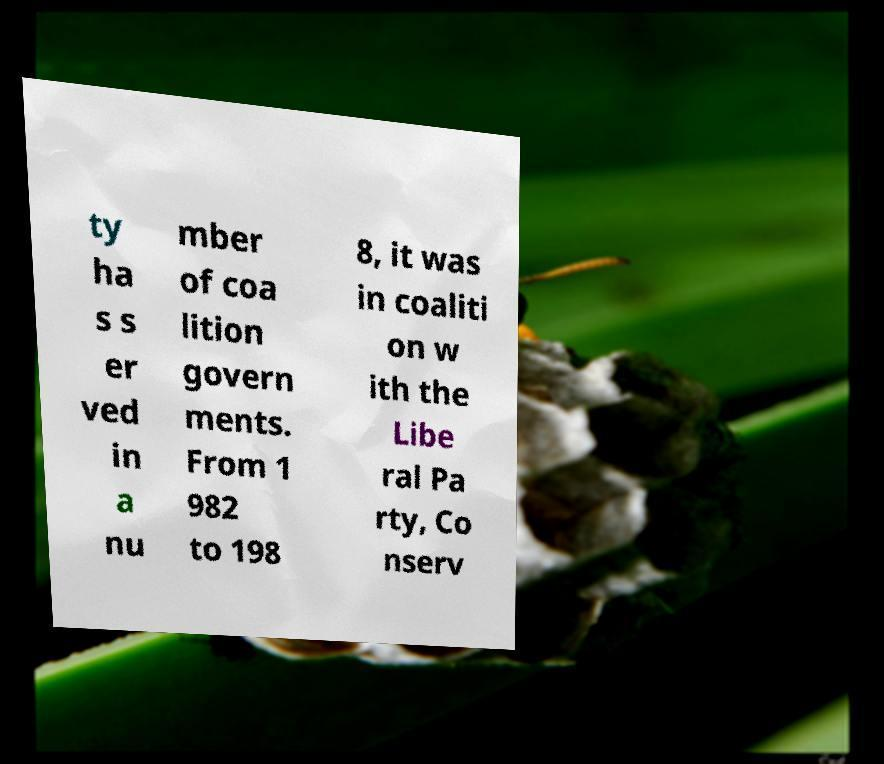For documentation purposes, I need the text within this image transcribed. Could you provide that? ty ha s s er ved in a nu mber of coa lition govern ments. From 1 982 to 198 8, it was in coaliti on w ith the Libe ral Pa rty, Co nserv 